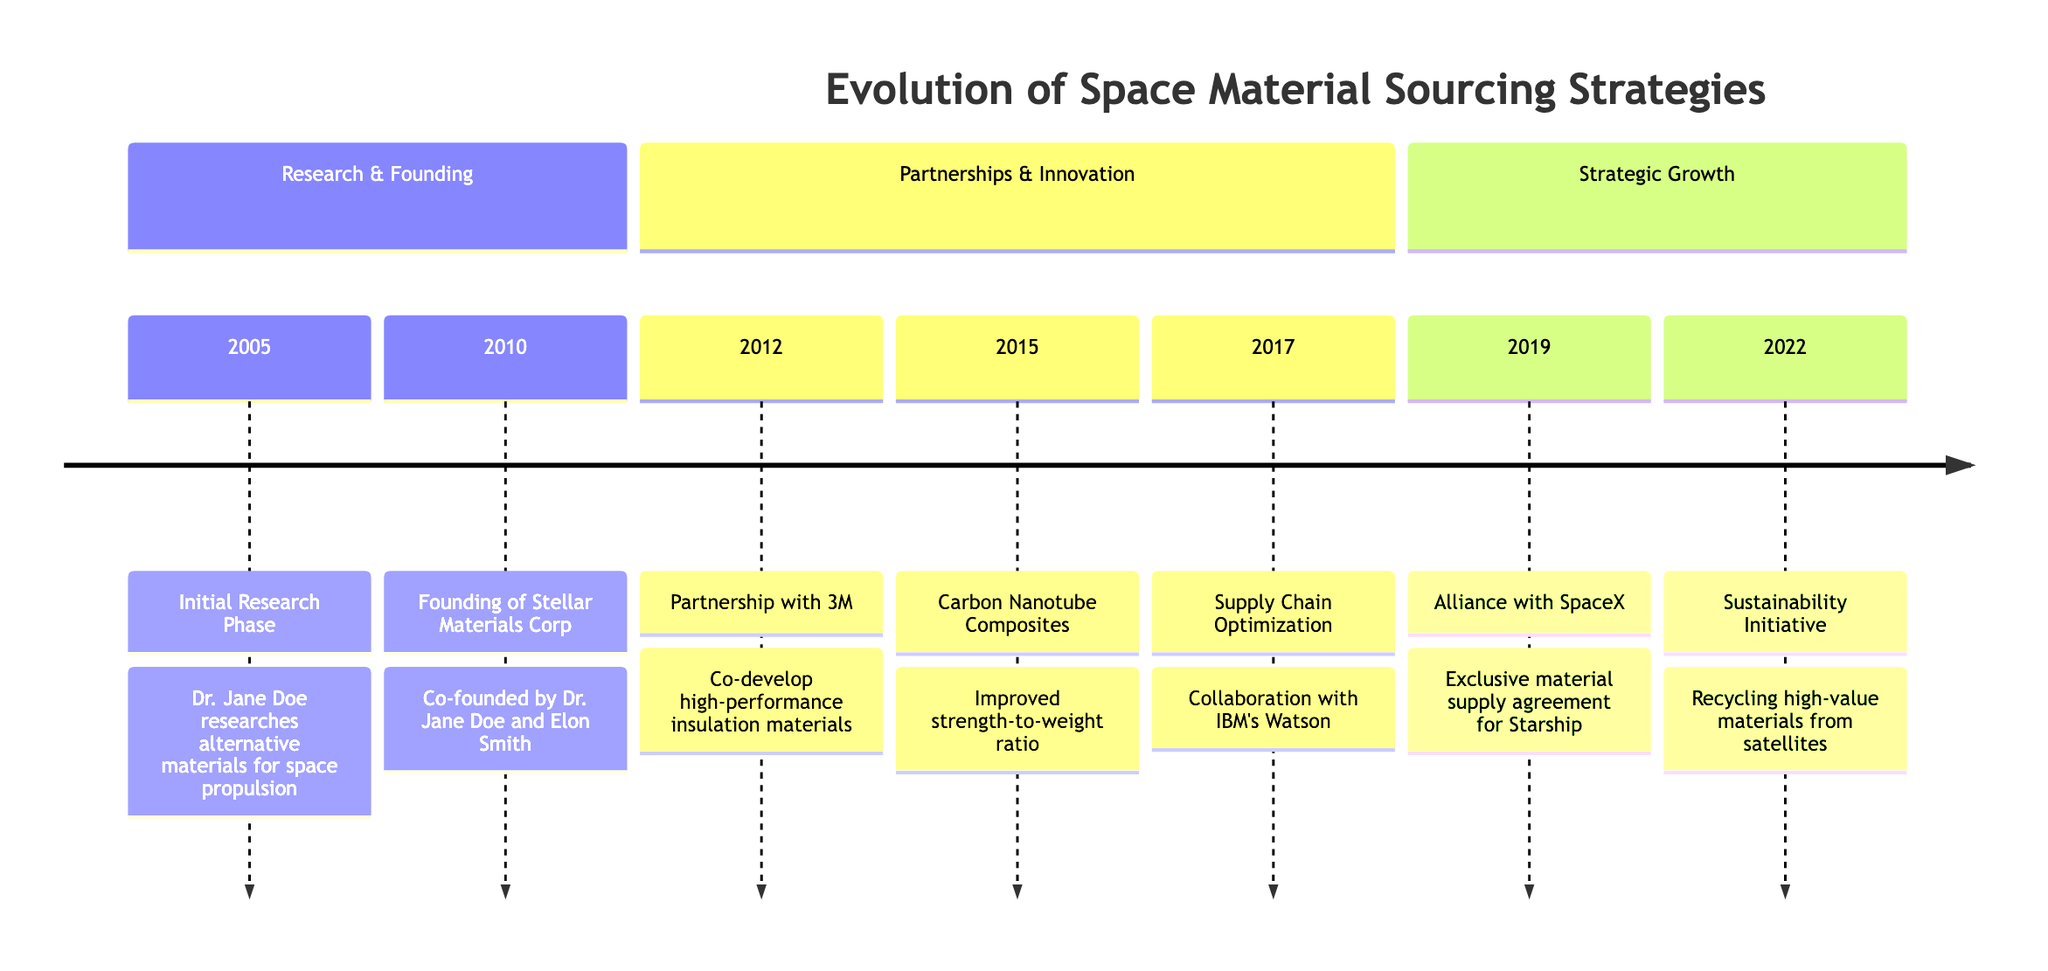What event occurred in 2015? The diagram indicates that in 2015, Stellar Materials Corp successfully integrated carbon nanotube composites.
Answer: Carbon Nanotube Composites What year did the partnership with 3M take place? From the timeline, the partnership with 3M is shown in the year 2012.
Answer: 2012 How many major events are listed before 2019? The timeline lists three major events prior to 2019: the Initial Research Phase, the founding of Stellar Materials Corp, and the partnership with 3M.
Answer: 3 Which company did Stellar Materials Corp collaborate with for supply chain optimization? The timeline states that Stellar Materials Corp collaborated with IBM's Watson for optimizing the supply chain.
Answer: IBM's Watson What was the focus of the sustainability initiative launched in 2022? According to the timeline, the sustainability initiative aimed at recycling high-value materials from decommissioned satellites.
Answer: Recycling high-value materials What does the exclusive material supply agreement with SpaceX pertain to? The timeline specifies that the exclusive material supply agreement with SpaceX is for the Starship program.
Answer: Starship Which year marks the founding of Stellar Materials Corp? The timeline clearly indicates that Stellar Materials Corp was founded in 2010.
Answer: 2010 What major technological advancement was introduced in 2015? The introduction of carbon nanotube composites is noted as a major technological advancement in 2015 in the timeline.
Answer: Carbon Nanotube Composites 